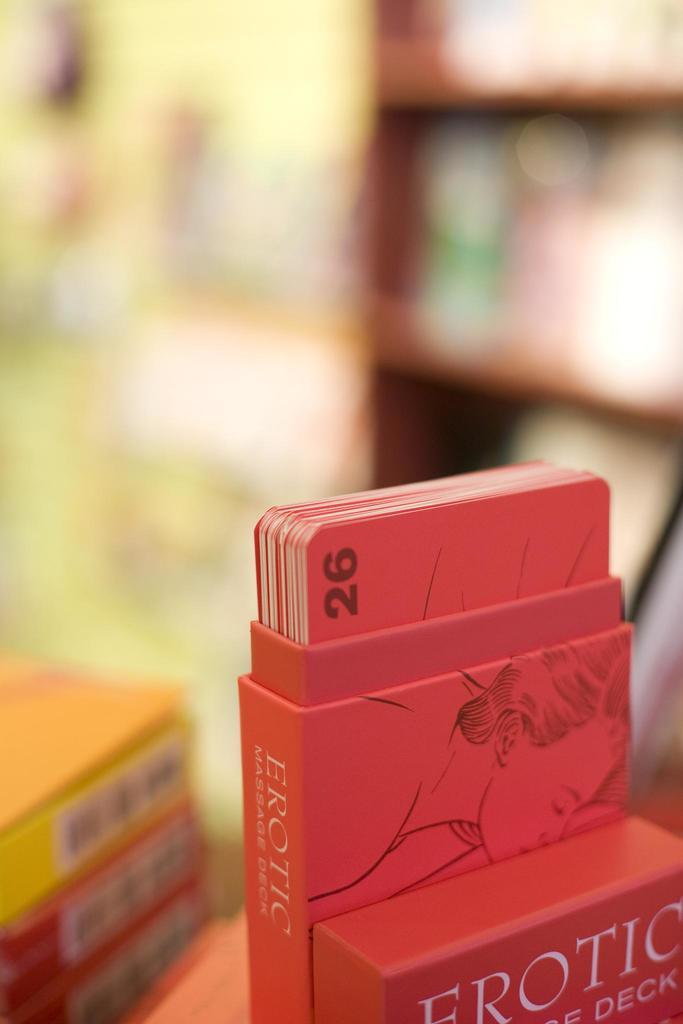<image>
Share a concise interpretation of the image provided. A set of adult playing cards goes by the name Erotic Massage Deck. 